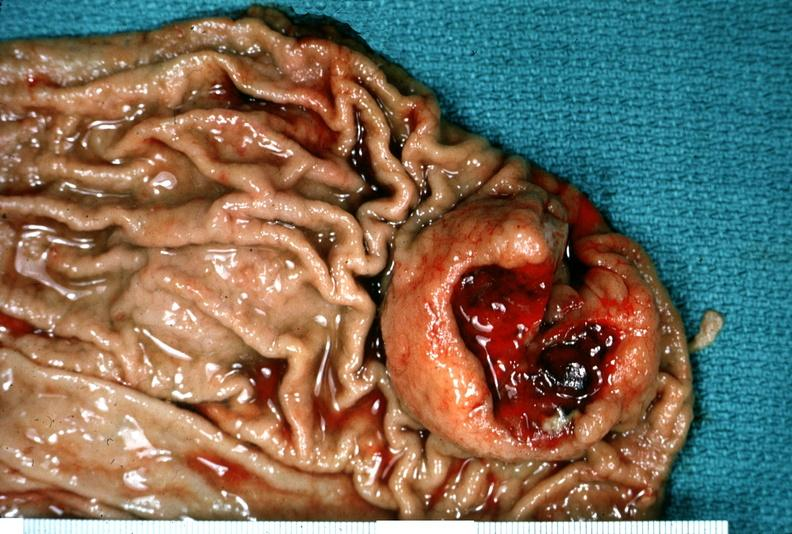s lymphangiomatosis present?
Answer the question using a single word or phrase. No 